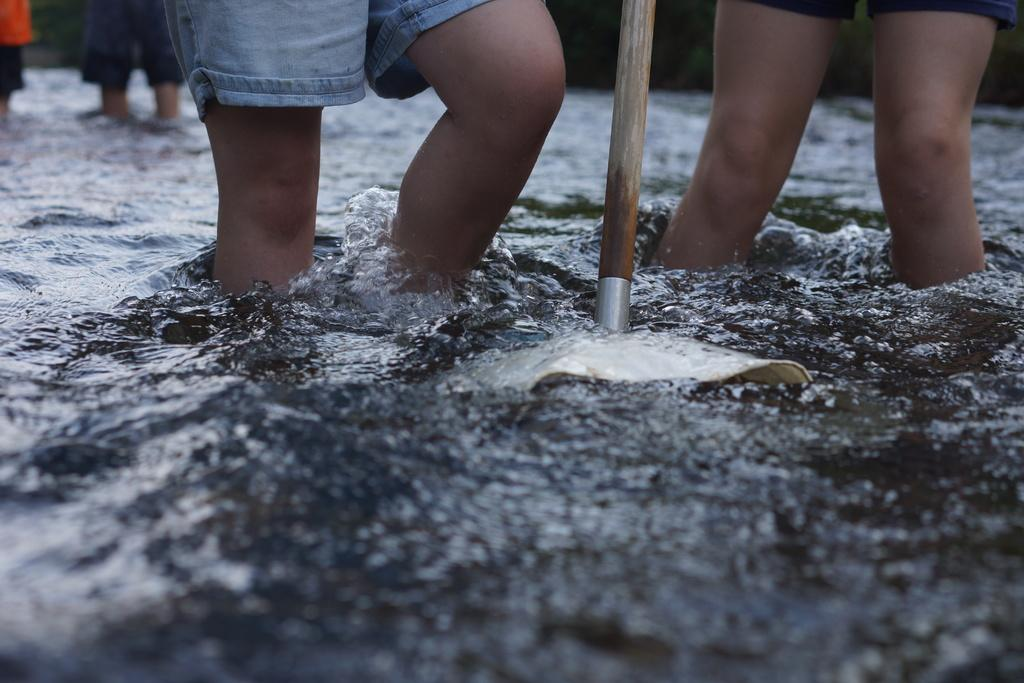What can be seen in the image that is related to water? There is water visible in the image. image. What object is made of wood and can be seen in the image? There is a wooden stick in the image. Can you describe any body parts visible in the image? Legs of persons are present in the image. What type of game is being played in the bedroom in the image? There is no game or bedroom present in the image; it only shows water, a wooden stick, and legs of persons. How does the breath of the persons affect the water in the image? There is no information about the breath of the persons or its effect on the water in the image. 